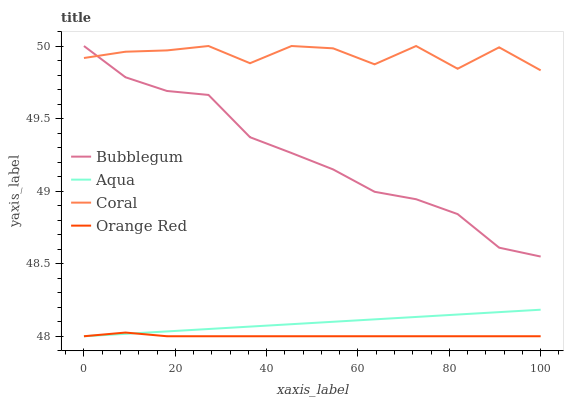Does Orange Red have the minimum area under the curve?
Answer yes or no. Yes. Does Coral have the maximum area under the curve?
Answer yes or no. Yes. Does Aqua have the minimum area under the curve?
Answer yes or no. No. Does Aqua have the maximum area under the curve?
Answer yes or no. No. Is Aqua the smoothest?
Answer yes or no. Yes. Is Coral the roughest?
Answer yes or no. Yes. Is Orange Red the smoothest?
Answer yes or no. No. Is Orange Red the roughest?
Answer yes or no. No. Does Bubblegum have the lowest value?
Answer yes or no. No. Does Aqua have the highest value?
Answer yes or no. No. Is Aqua less than Coral?
Answer yes or no. Yes. Is Coral greater than Aqua?
Answer yes or no. Yes. Does Aqua intersect Coral?
Answer yes or no. No. 